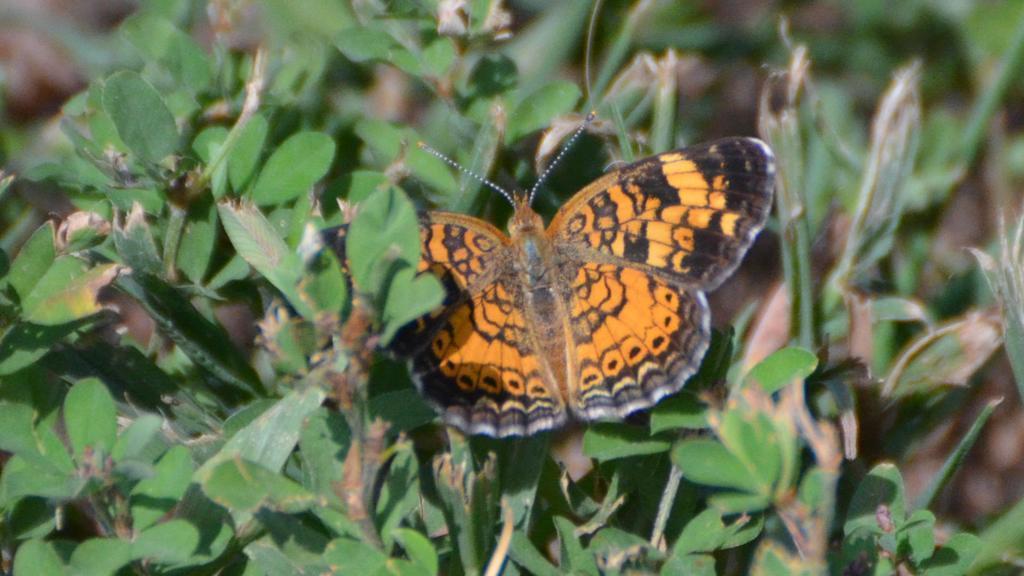Please provide a concise description of this image. In the middle I can see a butterfly on the plants. This image is taken may be during a day in a garden. 